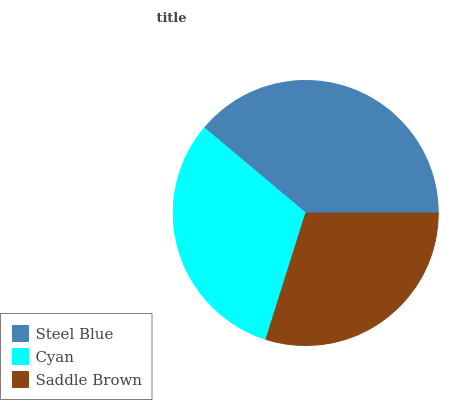Is Saddle Brown the minimum?
Answer yes or no. Yes. Is Steel Blue the maximum?
Answer yes or no. Yes. Is Cyan the minimum?
Answer yes or no. No. Is Cyan the maximum?
Answer yes or no. No. Is Steel Blue greater than Cyan?
Answer yes or no. Yes. Is Cyan less than Steel Blue?
Answer yes or no. Yes. Is Cyan greater than Steel Blue?
Answer yes or no. No. Is Steel Blue less than Cyan?
Answer yes or no. No. Is Cyan the high median?
Answer yes or no. Yes. Is Cyan the low median?
Answer yes or no. Yes. Is Steel Blue the high median?
Answer yes or no. No. Is Steel Blue the low median?
Answer yes or no. No. 